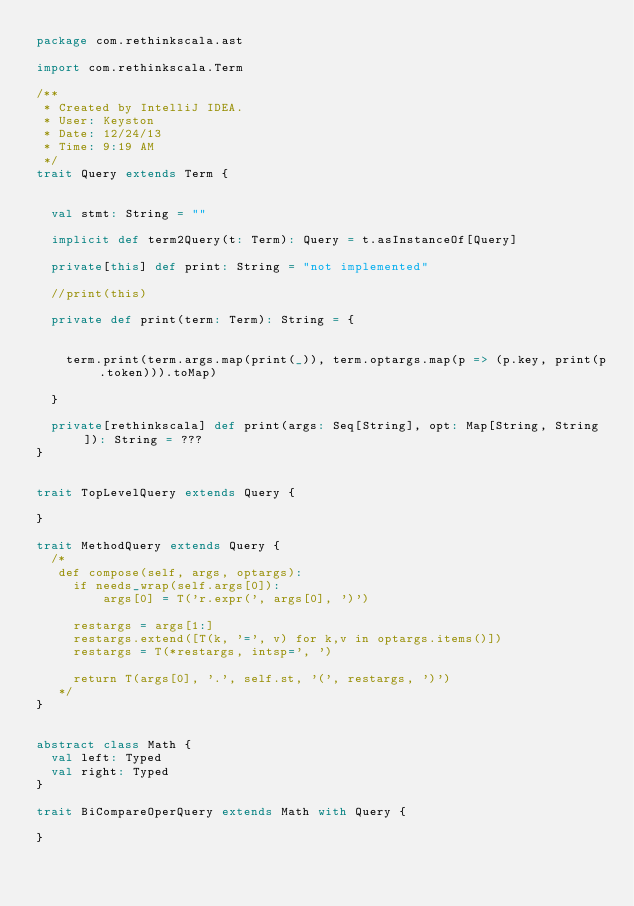<code> <loc_0><loc_0><loc_500><loc_500><_Scala_>package com.rethinkscala.ast

import com.rethinkscala.Term

/**
 * Created by IntelliJ IDEA.
 * User: Keyston
 * Date: 12/24/13
 * Time: 9:19 AM 
 */
trait Query extends Term {


  val stmt: String = ""

  implicit def term2Query(t: Term): Query = t.asInstanceOf[Query]

  private[this] def print: String = "not implemented"

  //print(this)

  private def print(term: Term): String = {


    term.print(term.args.map(print(_)), term.optargs.map(p => (p.key, print(p.token))).toMap)

  }

  private[rethinkscala] def print(args: Seq[String], opt: Map[String, String]): String = ???
}


trait TopLevelQuery extends Query {

}

trait MethodQuery extends Query {
  /*
   def compose(self, args, optargs):
     if needs_wrap(self.args[0]):
         args[0] = T('r.expr(', args[0], ')')

     restargs = args[1:]
     restargs.extend([T(k, '=', v) for k,v in optargs.items()])
     restargs = T(*restargs, intsp=', ')

     return T(args[0], '.', self.st, '(', restargs, ')')
   */
}


abstract class Math {
  val left: Typed
  val right: Typed
}

trait BiCompareOperQuery extends Math with Query {

}</code> 